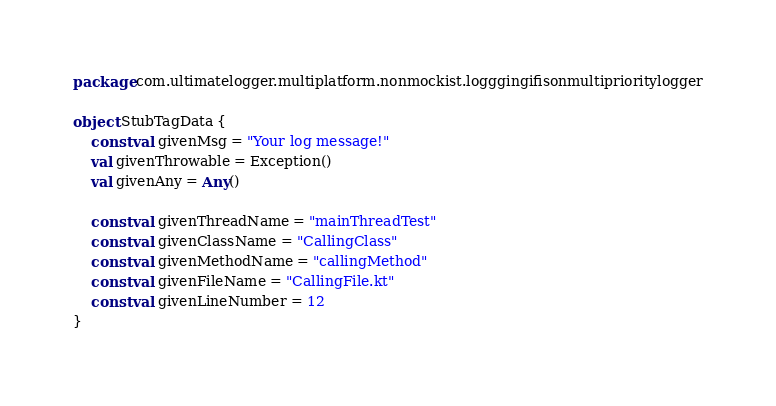Convert code to text. <code><loc_0><loc_0><loc_500><loc_500><_Kotlin_>package com.ultimatelogger.multiplatform.nonmockist.logggingifisonmultiprioritylogger

object StubTagData {
    const val givenMsg = "Your log message!"
    val givenThrowable = Exception()
    val givenAny = Any()

    const val givenThreadName = "mainThreadTest"
    const val givenClassName = "CallingClass"
    const val givenMethodName = "callingMethod"
    const val givenFileName = "CallingFile.kt"
    const val givenLineNumber = 12
}</code> 